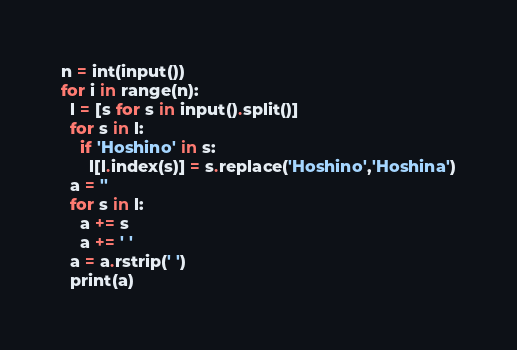<code> <loc_0><loc_0><loc_500><loc_500><_Python_>n = int(input())
for i in range(n):
  l = [s for s in input().split()]
  for s in l:
    if 'Hoshino' in s:
      l[l.index(s)] = s.replace('Hoshino','Hoshina')
  a = ''
  for s in l:
    a += s
    a += ' '
  a = a.rstrip(' ')
  print(a)</code> 